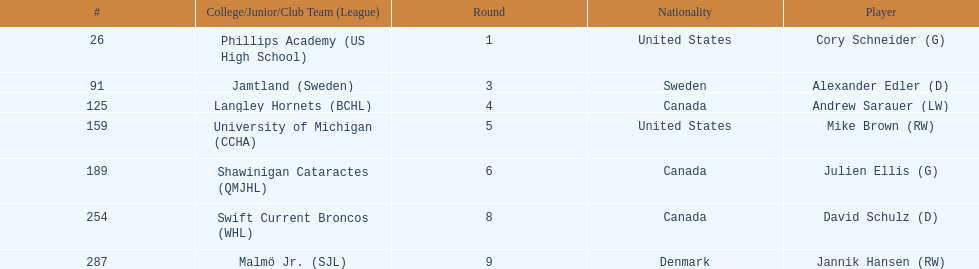Which player was the first player to be drafted? Cory Schneider (G). 